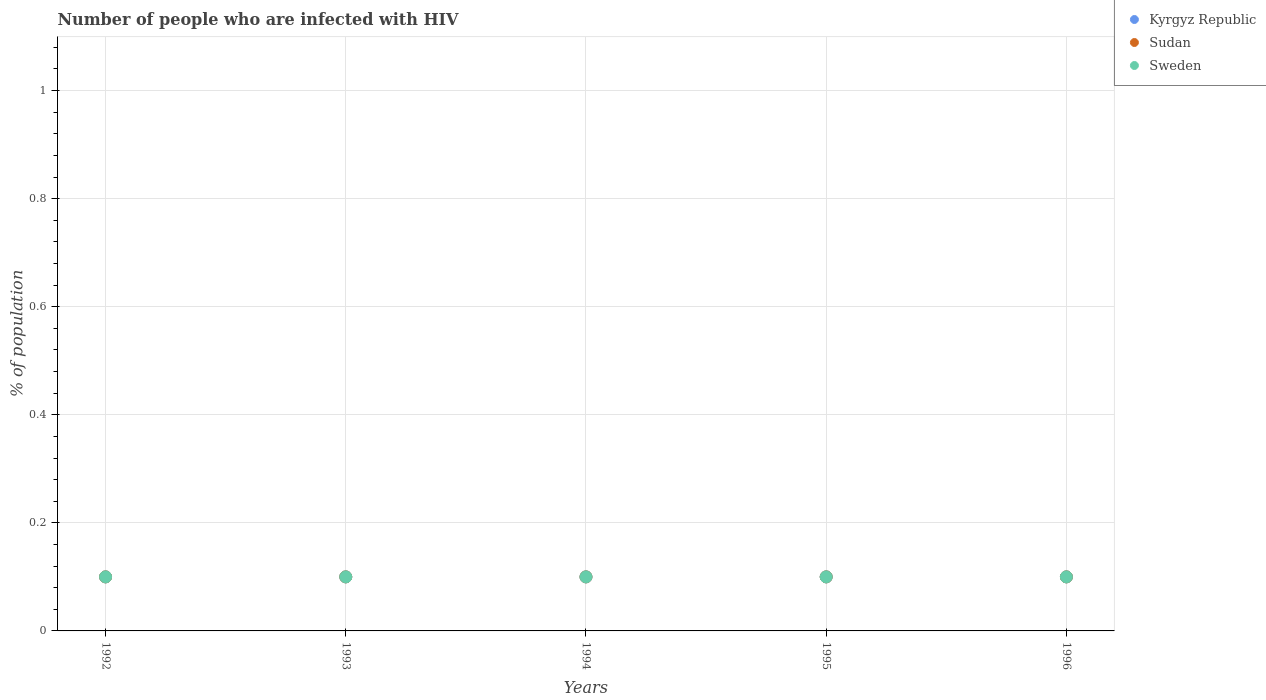How many different coloured dotlines are there?
Your response must be concise. 3. What is the percentage of HIV infected population in in Kyrgyz Republic in 1993?
Offer a terse response. 0.1. Across all years, what is the maximum percentage of HIV infected population in in Kyrgyz Republic?
Keep it short and to the point. 0.1. Across all years, what is the minimum percentage of HIV infected population in in Sudan?
Make the answer very short. 0.1. In which year was the percentage of HIV infected population in in Sudan maximum?
Give a very brief answer. 1992. In which year was the percentage of HIV infected population in in Kyrgyz Republic minimum?
Offer a very short reply. 1992. What is the total percentage of HIV infected population in in Sweden in the graph?
Give a very brief answer. 0.5. What is the ratio of the percentage of HIV infected population in in Kyrgyz Republic in 1993 to that in 1996?
Keep it short and to the point. 1. Is the difference between the percentage of HIV infected population in in Kyrgyz Republic in 1993 and 1995 greater than the difference between the percentage of HIV infected population in in Sudan in 1993 and 1995?
Provide a short and direct response. No. What is the difference between the highest and the second highest percentage of HIV infected population in in Sudan?
Offer a very short reply. 0. What is the difference between the highest and the lowest percentage of HIV infected population in in Sweden?
Provide a succinct answer. 0. In how many years, is the percentage of HIV infected population in in Sudan greater than the average percentage of HIV infected population in in Sudan taken over all years?
Offer a terse response. 0. Is it the case that in every year, the sum of the percentage of HIV infected population in in Kyrgyz Republic and percentage of HIV infected population in in Sudan  is greater than the percentage of HIV infected population in in Sweden?
Provide a short and direct response. Yes. Does the percentage of HIV infected population in in Sudan monotonically increase over the years?
Keep it short and to the point. No. Are the values on the major ticks of Y-axis written in scientific E-notation?
Your response must be concise. No. Does the graph contain any zero values?
Your answer should be compact. No. Does the graph contain grids?
Provide a short and direct response. Yes. Where does the legend appear in the graph?
Make the answer very short. Top right. How many legend labels are there?
Make the answer very short. 3. What is the title of the graph?
Provide a succinct answer. Number of people who are infected with HIV. Does "Czech Republic" appear as one of the legend labels in the graph?
Give a very brief answer. No. What is the label or title of the Y-axis?
Offer a very short reply. % of population. What is the % of population of Kyrgyz Republic in 1992?
Ensure brevity in your answer.  0.1. What is the % of population of Sudan in 1992?
Offer a terse response. 0.1. What is the % of population of Sweden in 1992?
Your answer should be very brief. 0.1. What is the % of population of Kyrgyz Republic in 1993?
Provide a short and direct response. 0.1. What is the % of population of Sudan in 1993?
Provide a succinct answer. 0.1. What is the % of population in Sudan in 1994?
Offer a very short reply. 0.1. What is the % of population of Sweden in 1994?
Make the answer very short. 0.1. What is the % of population in Kyrgyz Republic in 1995?
Offer a terse response. 0.1. What is the % of population of Sudan in 1995?
Your response must be concise. 0.1. What is the % of population in Sudan in 1996?
Make the answer very short. 0.1. What is the % of population in Sweden in 1996?
Ensure brevity in your answer.  0.1. Across all years, what is the maximum % of population of Kyrgyz Republic?
Make the answer very short. 0.1. Across all years, what is the maximum % of population of Sudan?
Your answer should be very brief. 0.1. Across all years, what is the minimum % of population of Sudan?
Provide a short and direct response. 0.1. What is the total % of population of Kyrgyz Republic in the graph?
Ensure brevity in your answer.  0.5. What is the total % of population in Sudan in the graph?
Provide a short and direct response. 0.5. What is the difference between the % of population in Kyrgyz Republic in 1992 and that in 1993?
Offer a terse response. 0. What is the difference between the % of population of Sweden in 1992 and that in 1993?
Offer a terse response. 0. What is the difference between the % of population in Sudan in 1992 and that in 1994?
Your answer should be compact. 0. What is the difference between the % of population in Sweden in 1992 and that in 1994?
Your response must be concise. 0. What is the difference between the % of population of Kyrgyz Republic in 1992 and that in 1995?
Your response must be concise. 0. What is the difference between the % of population in Sudan in 1992 and that in 1995?
Your answer should be very brief. 0. What is the difference between the % of population in Sweden in 1992 and that in 1995?
Provide a succinct answer. 0. What is the difference between the % of population of Sudan in 1992 and that in 1996?
Your answer should be very brief. 0. What is the difference between the % of population of Sweden in 1992 and that in 1996?
Your answer should be compact. 0. What is the difference between the % of population in Kyrgyz Republic in 1993 and that in 1994?
Make the answer very short. 0. What is the difference between the % of population of Sudan in 1993 and that in 1994?
Your answer should be compact. 0. What is the difference between the % of population of Sweden in 1993 and that in 1994?
Ensure brevity in your answer.  0. What is the difference between the % of population of Sweden in 1993 and that in 1996?
Your answer should be very brief. 0. What is the difference between the % of population in Kyrgyz Republic in 1994 and that in 1995?
Keep it short and to the point. 0. What is the difference between the % of population of Sweden in 1994 and that in 1995?
Ensure brevity in your answer.  0. What is the difference between the % of population in Kyrgyz Republic in 1994 and that in 1996?
Provide a short and direct response. 0. What is the difference between the % of population in Sudan in 1995 and that in 1996?
Ensure brevity in your answer.  0. What is the difference between the % of population of Sudan in 1992 and the % of population of Sweden in 1993?
Ensure brevity in your answer.  0. What is the difference between the % of population in Kyrgyz Republic in 1992 and the % of population in Sudan in 1994?
Keep it short and to the point. 0. What is the difference between the % of population in Kyrgyz Republic in 1992 and the % of population in Sweden in 1994?
Keep it short and to the point. 0. What is the difference between the % of population in Sudan in 1992 and the % of population in Sweden in 1994?
Your response must be concise. 0. What is the difference between the % of population in Kyrgyz Republic in 1992 and the % of population in Sudan in 1995?
Your answer should be compact. 0. What is the difference between the % of population of Sudan in 1992 and the % of population of Sweden in 1995?
Give a very brief answer. 0. What is the difference between the % of population of Sudan in 1992 and the % of population of Sweden in 1996?
Your answer should be compact. 0. What is the difference between the % of population of Kyrgyz Republic in 1993 and the % of population of Sweden in 1994?
Keep it short and to the point. 0. What is the difference between the % of population of Sudan in 1993 and the % of population of Sweden in 1994?
Ensure brevity in your answer.  0. What is the difference between the % of population of Kyrgyz Republic in 1993 and the % of population of Sudan in 1995?
Provide a succinct answer. 0. What is the difference between the % of population of Kyrgyz Republic in 1993 and the % of population of Sudan in 1996?
Provide a succinct answer. 0. What is the difference between the % of population in Kyrgyz Republic in 1994 and the % of population in Sweden in 1995?
Offer a very short reply. 0. What is the difference between the % of population of Sudan in 1994 and the % of population of Sweden in 1995?
Provide a short and direct response. 0. What is the difference between the % of population of Kyrgyz Republic in 1994 and the % of population of Sudan in 1996?
Your response must be concise. 0. What is the difference between the % of population in Kyrgyz Republic in 1994 and the % of population in Sweden in 1996?
Offer a very short reply. 0. What is the difference between the % of population in Sudan in 1994 and the % of population in Sweden in 1996?
Your answer should be very brief. 0. What is the difference between the % of population of Kyrgyz Republic in 1995 and the % of population of Sudan in 1996?
Your answer should be compact. 0. What is the average % of population in Sweden per year?
Provide a short and direct response. 0.1. In the year 1992, what is the difference between the % of population in Kyrgyz Republic and % of population in Sudan?
Give a very brief answer. 0. In the year 1992, what is the difference between the % of population in Sudan and % of population in Sweden?
Your answer should be compact. 0. In the year 1993, what is the difference between the % of population in Sudan and % of population in Sweden?
Ensure brevity in your answer.  0. In the year 1995, what is the difference between the % of population of Kyrgyz Republic and % of population of Sweden?
Ensure brevity in your answer.  0. What is the ratio of the % of population in Kyrgyz Republic in 1992 to that in 1993?
Keep it short and to the point. 1. What is the ratio of the % of population in Kyrgyz Republic in 1992 to that in 1994?
Keep it short and to the point. 1. What is the ratio of the % of population of Sudan in 1992 to that in 1994?
Your answer should be very brief. 1. What is the ratio of the % of population in Sudan in 1992 to that in 1995?
Offer a terse response. 1. What is the ratio of the % of population in Sudan in 1992 to that in 1996?
Your answer should be very brief. 1. What is the ratio of the % of population of Kyrgyz Republic in 1993 to that in 1994?
Offer a terse response. 1. What is the ratio of the % of population in Sweden in 1993 to that in 1994?
Offer a very short reply. 1. What is the ratio of the % of population of Kyrgyz Republic in 1993 to that in 1996?
Your answer should be compact. 1. What is the ratio of the % of population of Kyrgyz Republic in 1994 to that in 1995?
Keep it short and to the point. 1. What is the ratio of the % of population in Sudan in 1994 to that in 1995?
Offer a terse response. 1. What is the ratio of the % of population of Sweden in 1994 to that in 1995?
Provide a succinct answer. 1. What is the ratio of the % of population in Kyrgyz Republic in 1994 to that in 1996?
Keep it short and to the point. 1. What is the ratio of the % of population of Sweden in 1994 to that in 1996?
Your answer should be compact. 1. What is the ratio of the % of population of Kyrgyz Republic in 1995 to that in 1996?
Provide a short and direct response. 1. What is the ratio of the % of population in Sweden in 1995 to that in 1996?
Offer a terse response. 1. What is the difference between the highest and the second highest % of population of Sweden?
Offer a very short reply. 0. What is the difference between the highest and the lowest % of population of Sudan?
Make the answer very short. 0. 